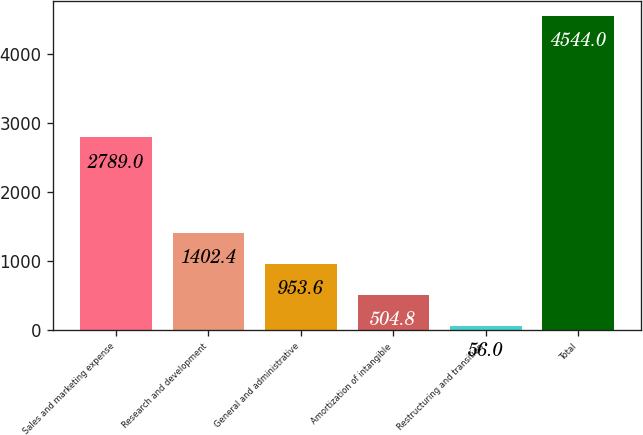Convert chart. <chart><loc_0><loc_0><loc_500><loc_500><bar_chart><fcel>Sales and marketing expense<fcel>Research and development<fcel>General and administrative<fcel>Amortization of intangible<fcel>Restructuring and transition<fcel>Total<nl><fcel>2789<fcel>1402.4<fcel>953.6<fcel>504.8<fcel>56<fcel>4544<nl></chart> 